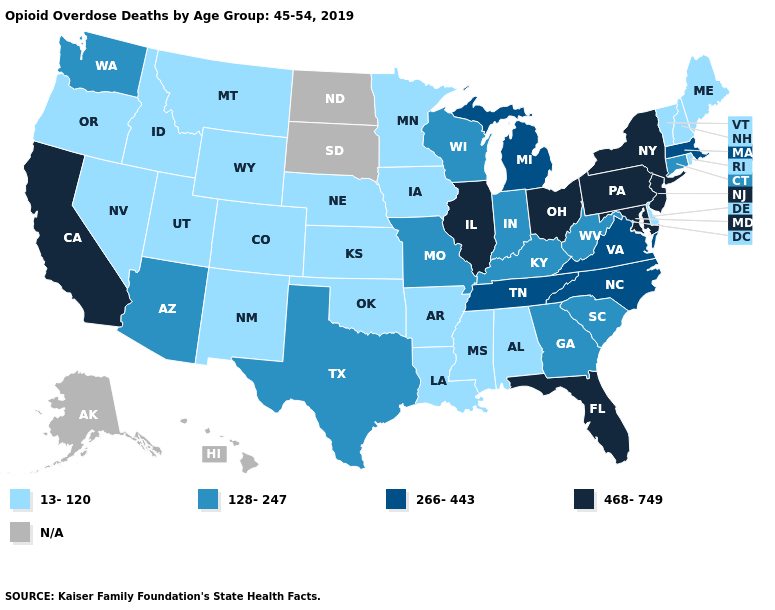Name the states that have a value in the range 128-247?
Quick response, please. Arizona, Connecticut, Georgia, Indiana, Kentucky, Missouri, South Carolina, Texas, Washington, West Virginia, Wisconsin. Does the first symbol in the legend represent the smallest category?
Keep it brief. Yes. What is the lowest value in the West?
Answer briefly. 13-120. Name the states that have a value in the range 266-443?
Be succinct. Massachusetts, Michigan, North Carolina, Tennessee, Virginia. What is the highest value in the USA?
Quick response, please. 468-749. What is the value of Rhode Island?
Short answer required. 13-120. What is the highest value in states that border West Virginia?
Give a very brief answer. 468-749. Name the states that have a value in the range 128-247?
Quick response, please. Arizona, Connecticut, Georgia, Indiana, Kentucky, Missouri, South Carolina, Texas, Washington, West Virginia, Wisconsin. Does the first symbol in the legend represent the smallest category?
Keep it brief. Yes. Which states hav the highest value in the MidWest?
Write a very short answer. Illinois, Ohio. Name the states that have a value in the range 128-247?
Concise answer only. Arizona, Connecticut, Georgia, Indiana, Kentucky, Missouri, South Carolina, Texas, Washington, West Virginia, Wisconsin. What is the value of California?
Short answer required. 468-749. Which states have the highest value in the USA?
Be succinct. California, Florida, Illinois, Maryland, New Jersey, New York, Ohio, Pennsylvania. Which states have the lowest value in the USA?
Give a very brief answer. Alabama, Arkansas, Colorado, Delaware, Idaho, Iowa, Kansas, Louisiana, Maine, Minnesota, Mississippi, Montana, Nebraska, Nevada, New Hampshire, New Mexico, Oklahoma, Oregon, Rhode Island, Utah, Vermont, Wyoming. 